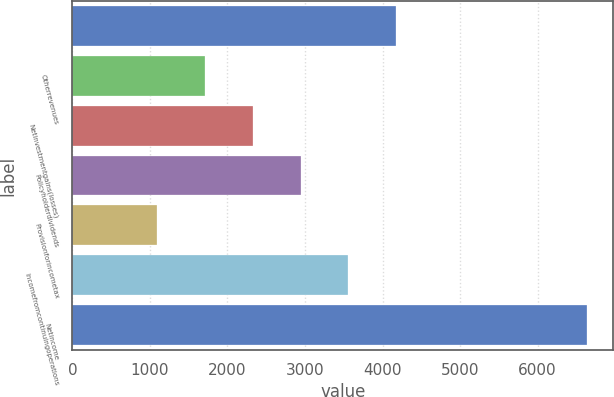Convert chart to OTSL. <chart><loc_0><loc_0><loc_500><loc_500><bar_chart><ecel><fcel>Otherrevenues<fcel>Netinvestmentgains(losses)<fcel>Policyholderdividends<fcel>Provisionforincometax<fcel>Incomefromcontinuingoperations<fcel>Netincome<nl><fcel>4176.5<fcel>1712.9<fcel>2328.8<fcel>2944.7<fcel>1097<fcel>3560.6<fcel>6640.1<nl></chart> 